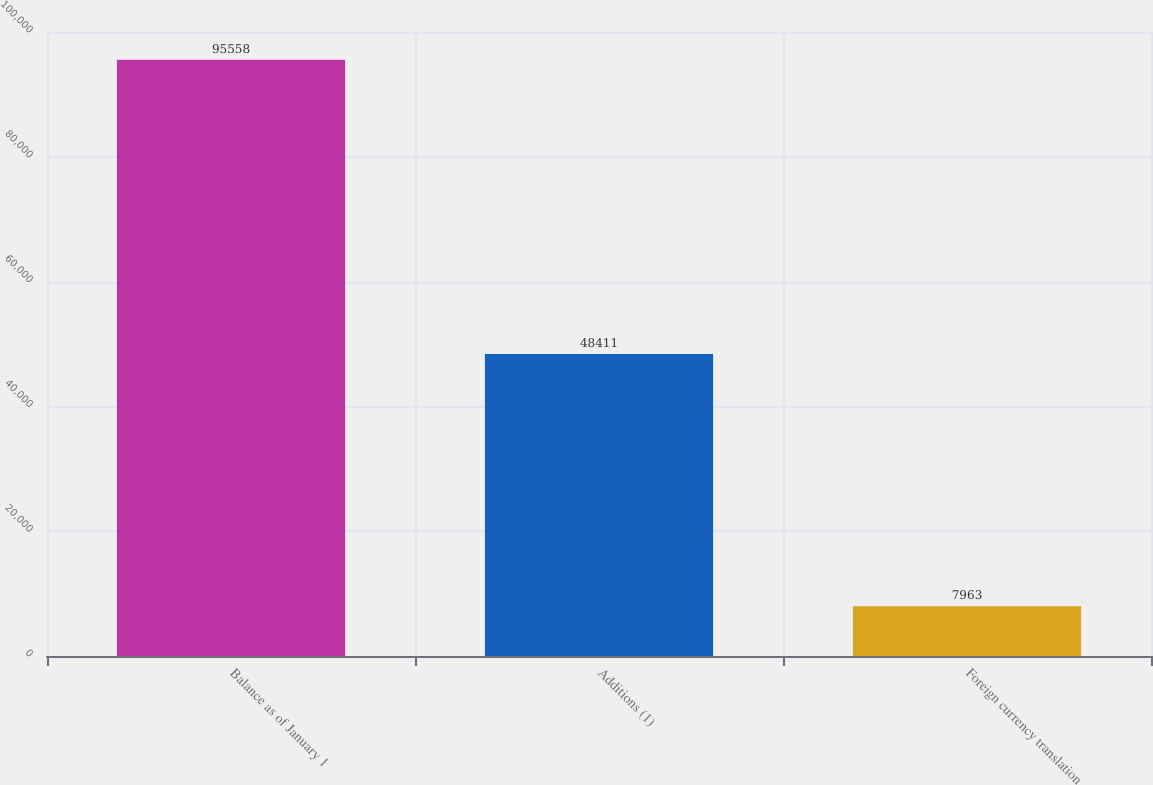Convert chart to OTSL. <chart><loc_0><loc_0><loc_500><loc_500><bar_chart><fcel>Balance as of January 1<fcel>Additions (1)<fcel>Foreign currency translation<nl><fcel>95558<fcel>48411<fcel>7963<nl></chart> 